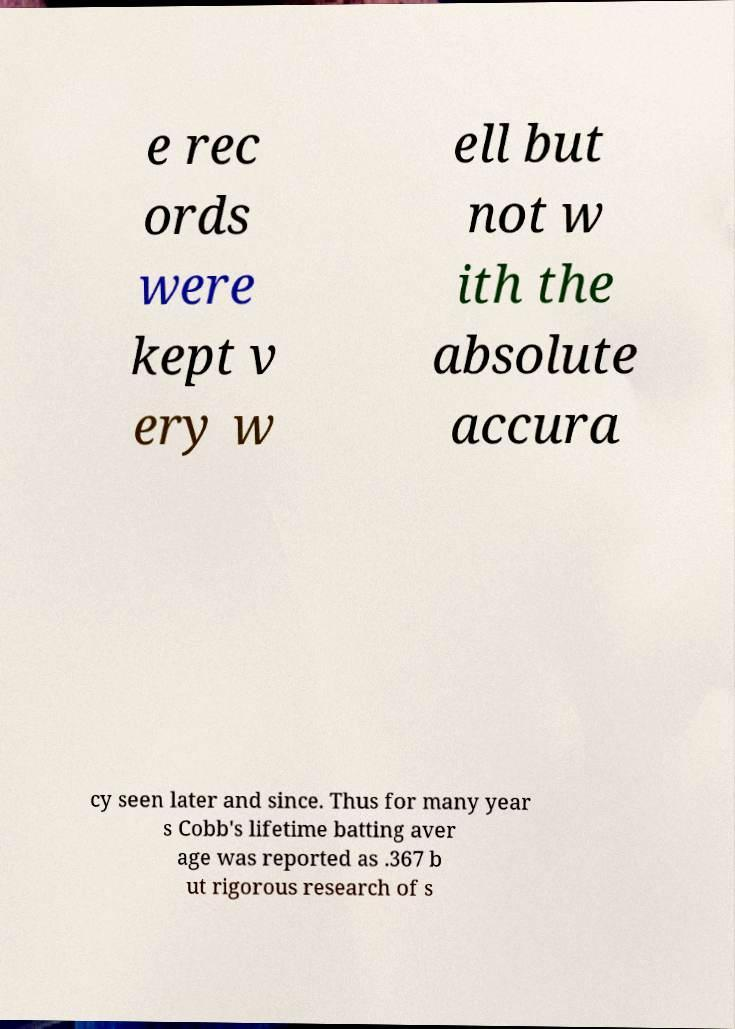Could you extract and type out the text from this image? e rec ords were kept v ery w ell but not w ith the absolute accura cy seen later and since. Thus for many year s Cobb's lifetime batting aver age was reported as .367 b ut rigorous research of s 